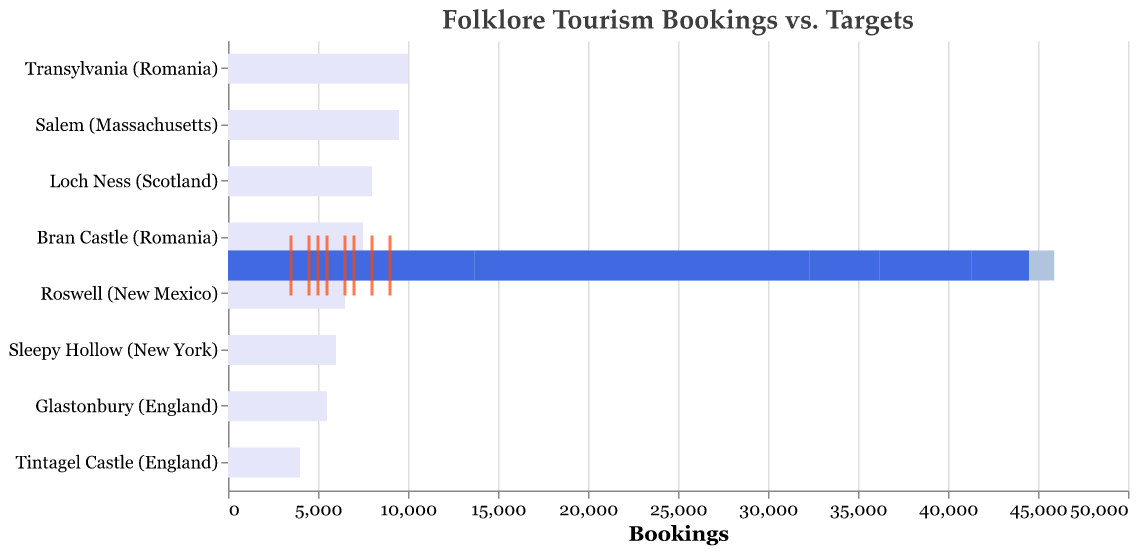What is the title of the chart? The title of the chart can be found at the top and reads "Folklore Tourism Bookings vs. Targets."
Answer: "Folklore Tourism Bookings vs. Targets" Which destination has the highest number of actual bookings? By observing the heights of the blue bars representing actual bookings, Salem (Massachusetts) has the highest at 8,300 bookings.
Answer: Salem (Massachusetts) What is the maximum possible bookings for Bran Castle (Romania)? The grey bar representing the maximum value for Bran Castle (Romania) indicates the maximum possible bookings are 7,500.
Answer: 7,500 For which destinations did actual bookings surpass the historical average? By comparing blue bars (actual bookings) and light blue bars (historical average), destinations where the actual bookings surpass the historical average include Salem (Massachusetts) and Sleepy Hollow (New York).
Answer: Salem (Massachusetts), Sleepy Hollow (New York) Which destinations did not meet their target bookings? The target bookings are represented by the orange ticks. Destinations where the blue bar (actual bookings) does not reach the tick include Transylvania (Romania), Loch Ness (Scotland), Sleepy Hollow (New York), Bran Castle (Romania), Glastonbury (England), Roswell (New Mexico), and Tintagel Castle (England).
Answer: Transylvania (Romania), Loch Ness (Scotland), Sleepy Hollow (New York), Bran Castle (Romania), Glastonbury (England), Roswell (New Mexico), Tintagel Castle (England) What is the difference between the actual bookings and the target for Loch Ness (Scotland)? The actual bookings for Loch Ness (Scotland) are 6,200, and the target is 7,000. The difference is 7,000 - 6,200 = 800.
Answer: 800 Which destinations have actual bookings that are above 5,000? By looking for blue bars that extend beyond the 5,000 mark on the x-axis, these destinations include Transylvania (Romania), Loch Ness (Scotland), Salem (Massachusetts), Bran Castle (Romania), and Roswell (New Mexico).
Answer: Transylvania (Romania), Loch Ness (Scotland), Salem (Massachusetts), Bran Castle (Romania), Roswell (New Mexico) Are there any destinations where actual bookings and targets are equal? Comparing the blue bars with the orange ticks, only Salem (Massachusetts) shows actual bookings of 8,300 which meets its target of 8,000. None of the other destinations have this equality.
Answer: No What is the combined actual bookings for all destinations mentioned? Adding up all the actual bookings: 7,500 (Transylvania) + 6,200 (Loch Ness) + 8,300 (Salem) + 4,500 (Sleepy Hollow) + 5,800 (Bran Castle) + 3,900 (Glastonbury) + 5,100 (Roswell) + 3,200 (Tintagel Castle) = 44,500.
Answer: 44,500 Considering historical averages and targets, which destination has the smallest gap between these two metrics? By calculating the difference for each destination: 
Transylvania (9000-8000=1000), Loch Ness (7000-6500=500), Salem (8000-7800=200), Sleepy Hollow (5000-4800=200), Bran Castle (6500-6000=500), Glastonbury (4500-4200=300), Roswell (5500-5300=200), Tintagel Castle (3500-3300=200). Multiple destinations tied at 200 differences, namely Salem, Sleepy Hollow, Roswell, and Tintagel Castle.
Answer: Salem (Massachusetts), Sleepy Hollow (New York), Roswell (New Mexico), Tintagel Castle (England) 